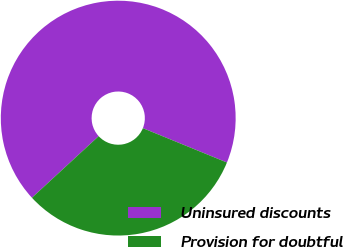Convert chart. <chart><loc_0><loc_0><loc_500><loc_500><pie_chart><fcel>Uninsured discounts<fcel>Provision for doubtful<nl><fcel>68.03%<fcel>31.97%<nl></chart> 